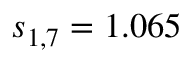<formula> <loc_0><loc_0><loc_500><loc_500>s _ { 1 , 7 } = 1 . 0 6 5</formula> 